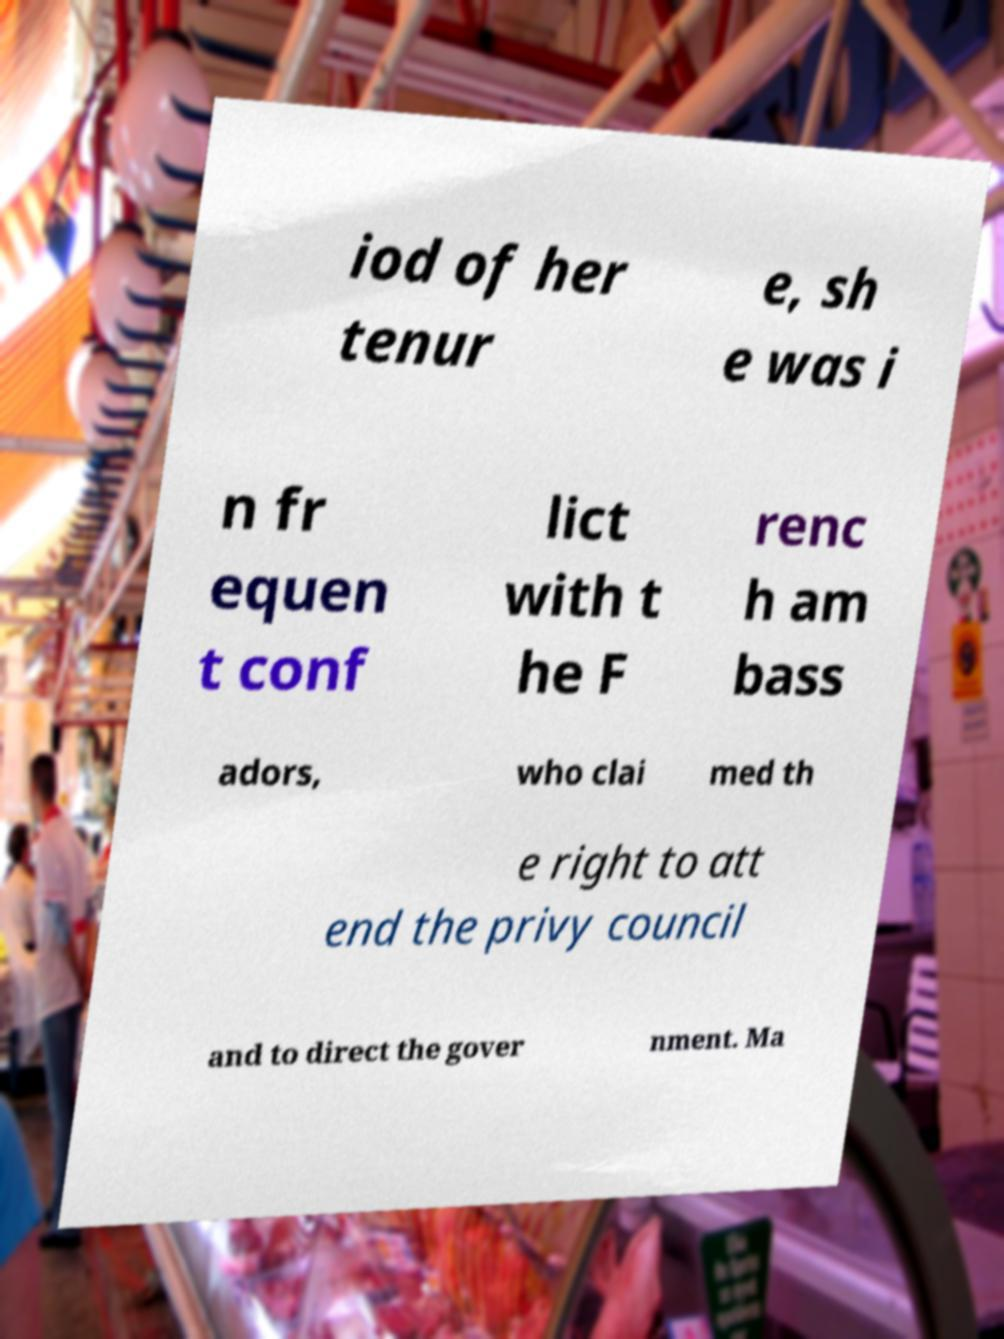Please read and relay the text visible in this image. What does it say? iod of her tenur e, sh e was i n fr equen t conf lict with t he F renc h am bass adors, who clai med th e right to att end the privy council and to direct the gover nment. Ma 